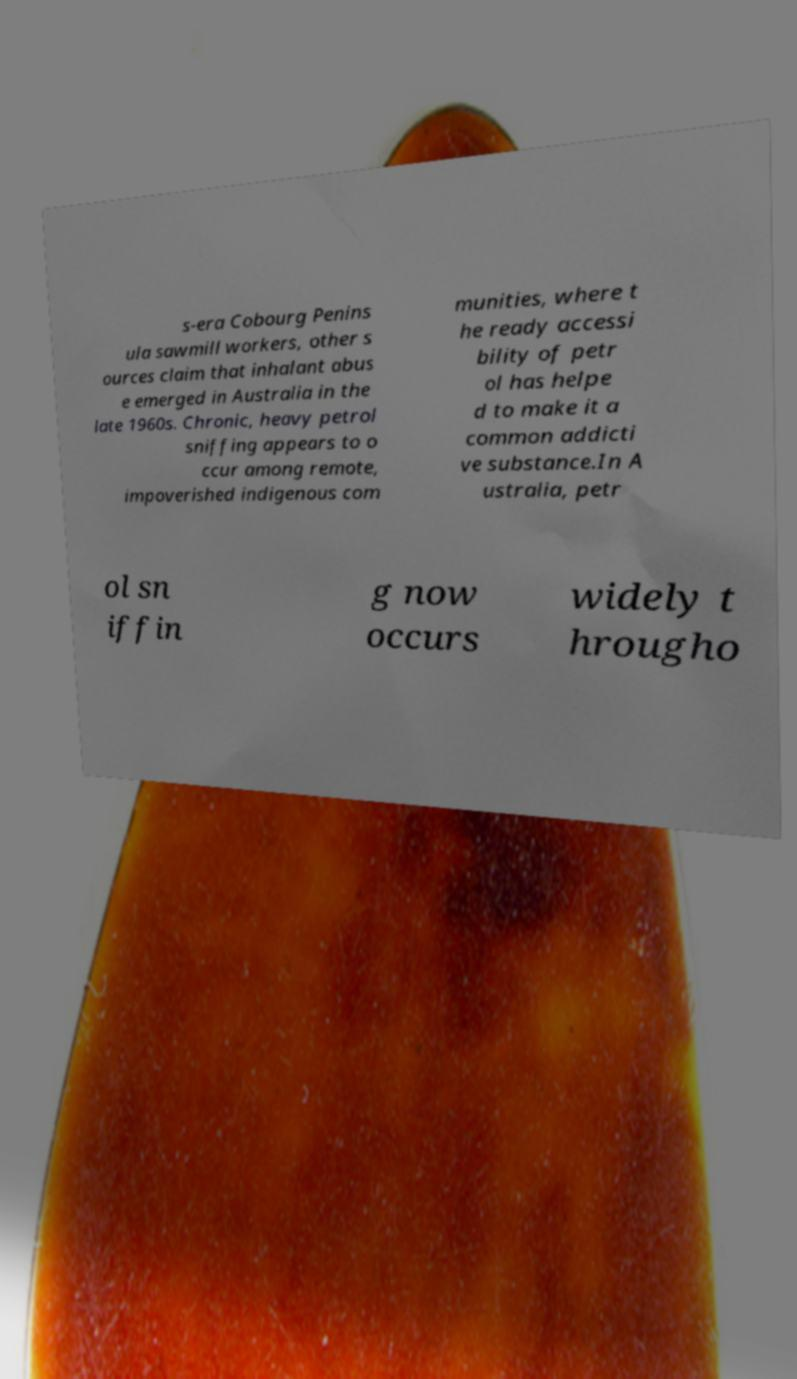Can you read and provide the text displayed in the image?This photo seems to have some interesting text. Can you extract and type it out for me? s-era Cobourg Penins ula sawmill workers, other s ources claim that inhalant abus e emerged in Australia in the late 1960s. Chronic, heavy petrol sniffing appears to o ccur among remote, impoverished indigenous com munities, where t he ready accessi bility of petr ol has helpe d to make it a common addicti ve substance.In A ustralia, petr ol sn iffin g now occurs widely t hrougho 